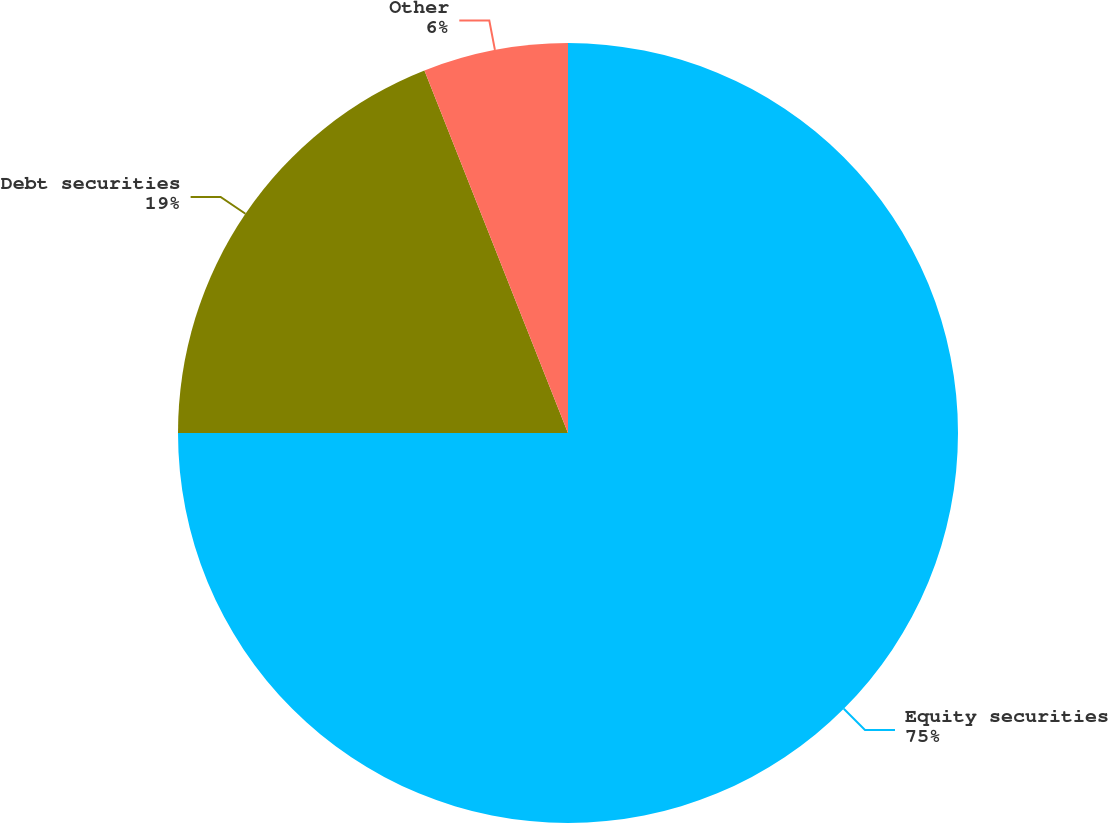Convert chart. <chart><loc_0><loc_0><loc_500><loc_500><pie_chart><fcel>Equity securities<fcel>Debt securities<fcel>Other<nl><fcel>75.0%<fcel>19.0%<fcel>6.0%<nl></chart> 